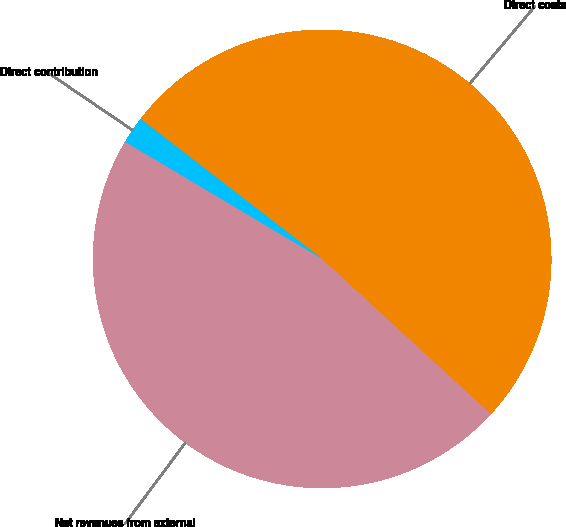Convert chart to OTSL. <chart><loc_0><loc_0><loc_500><loc_500><pie_chart><fcel>Net revenues from external<fcel>Direct costs<fcel>Direct contribution<nl><fcel>46.71%<fcel>51.38%<fcel>1.91%<nl></chart> 